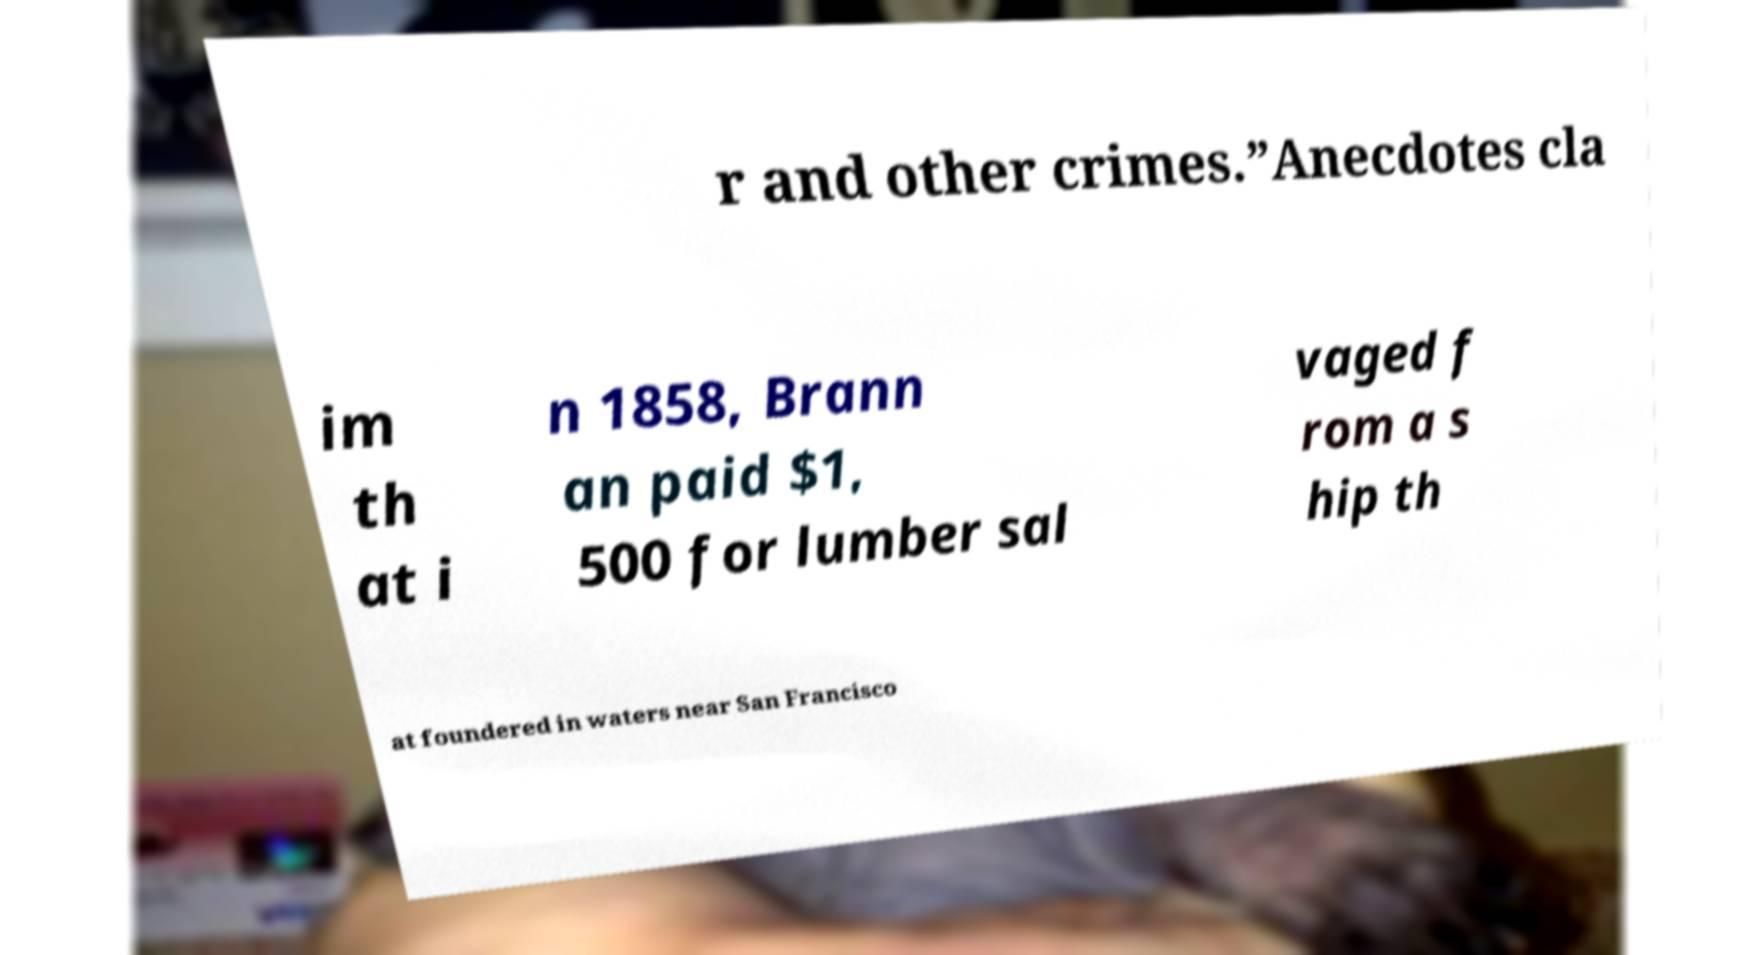I need the written content from this picture converted into text. Can you do that? r and other crimes.”Anecdotes cla im th at i n 1858, Brann an paid $1, 500 for lumber sal vaged f rom a s hip th at foundered in waters near San Francisco 